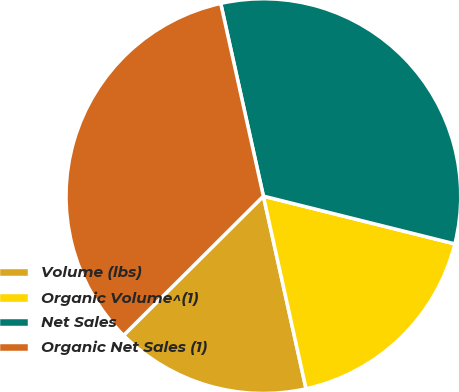Convert chart to OTSL. <chart><loc_0><loc_0><loc_500><loc_500><pie_chart><fcel>Volume (lbs)<fcel>Organic Volume^(1)<fcel>Net Sales<fcel>Organic Net Sales (1)<nl><fcel>16.0%<fcel>17.64%<fcel>32.36%<fcel>34.0%<nl></chart> 